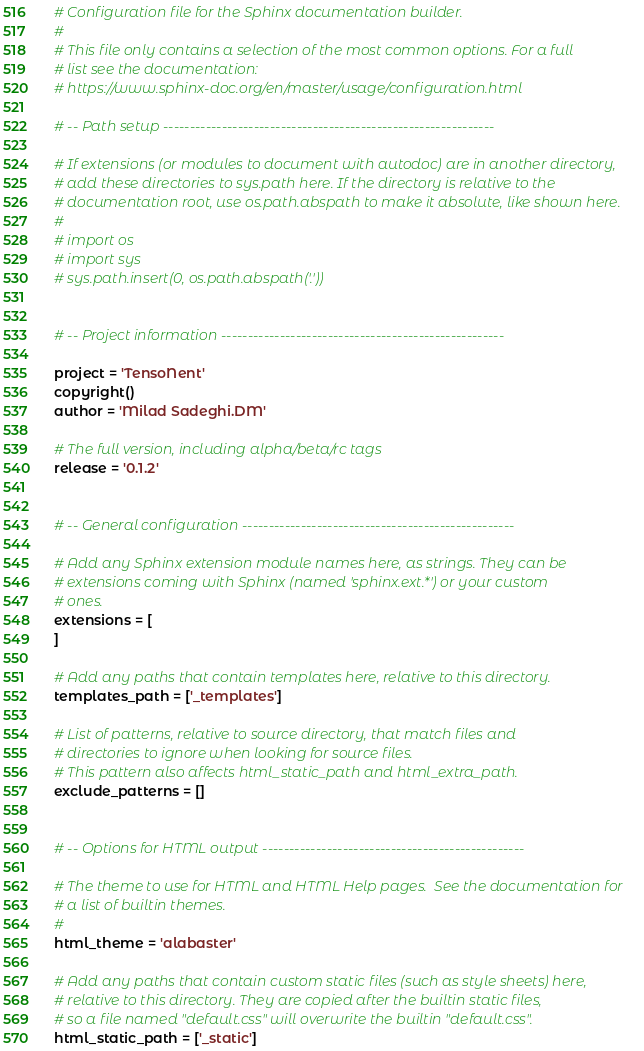Convert code to text. <code><loc_0><loc_0><loc_500><loc_500><_Python_># Configuration file for the Sphinx documentation builder.
#
# This file only contains a selection of the most common options. For a full
# list see the documentation:
# https://www.sphinx-doc.org/en/master/usage/configuration.html

# -- Path setup --------------------------------------------------------------

# If extensions (or modules to document with autodoc) are in another directory,
# add these directories to sys.path here. If the directory is relative to the
# documentation root, use os.path.abspath to make it absolute, like shown here.
#
# import os
# import sys
# sys.path.insert(0, os.path.abspath('.'))


# -- Project information -----------------------------------------------------

project = 'TensoNent'
copyright()
author = 'Milad Sadeghi.DM'

# The full version, including alpha/beta/rc tags
release = '0.1.2'


# -- General configuration ---------------------------------------------------

# Add any Sphinx extension module names here, as strings. They can be
# extensions coming with Sphinx (named 'sphinx.ext.*') or your custom
# ones.
extensions = [
]

# Add any paths that contain templates here, relative to this directory.
templates_path = ['_templates']

# List of patterns, relative to source directory, that match files and
# directories to ignore when looking for source files.
# This pattern also affects html_static_path and html_extra_path.
exclude_patterns = []


# -- Options for HTML output -------------------------------------------------

# The theme to use for HTML and HTML Help pages.  See the documentation for
# a list of builtin themes.
#
html_theme = 'alabaster'

# Add any paths that contain custom static files (such as style sheets) here,
# relative to this directory. They are copied after the builtin static files,
# so a file named "default.css" will overwrite the builtin "default.css".
html_static_path = ['_static']
</code> 